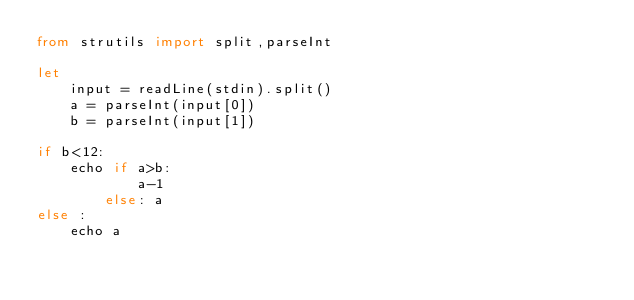Convert code to text. <code><loc_0><loc_0><loc_500><loc_500><_Nim_>from strutils import split,parseInt

let 
    input = readLine(stdin).split()
    a = parseInt(input[0])
    b = parseInt(input[1])

if b<12:
    echo if a>b:
            a-1
        else: a
else :
    echo a </code> 